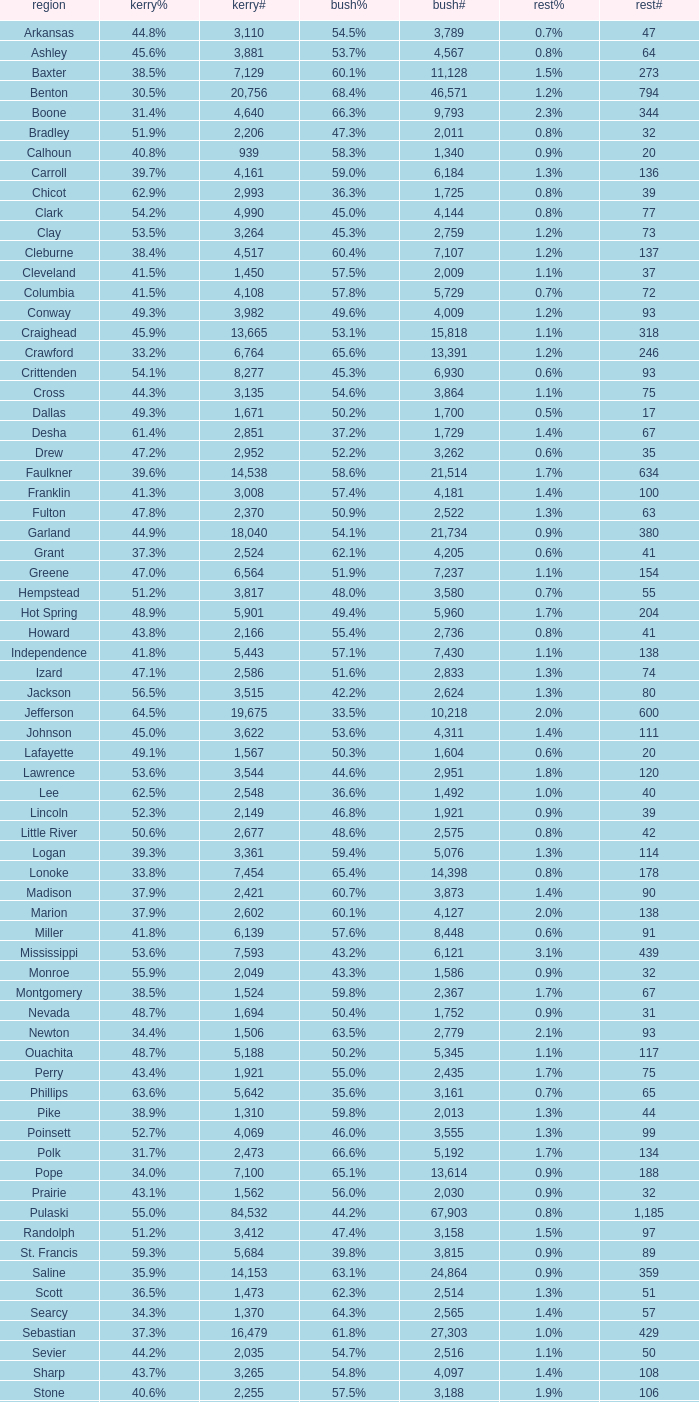What is the lowest Kerry#, when Others# is "106", and when Bush# is less than 3,188? None. 